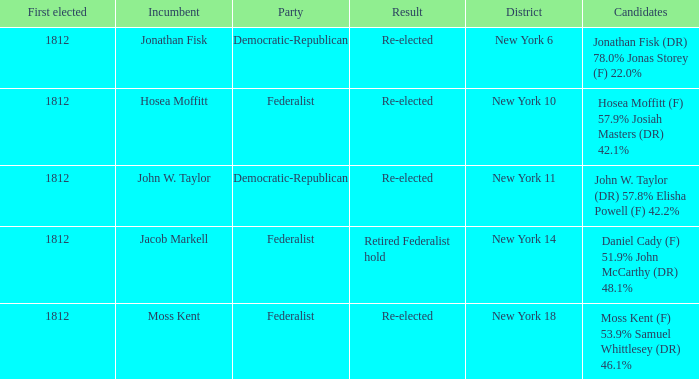Name the first elected for hosea moffitt (f) 57.9% josiah masters (dr) 42.1% 1812.0. 